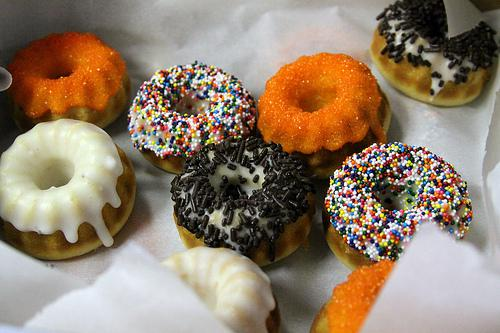Question: where was this photo taken?
Choices:
A. The pizza parlor.
B. The taco stand.
C. The grocery store.
D. The bakery.
Answer with the letter. Answer: D Question: when was this photo taken?
Choices:
A. Today.
B. Last week.
C. Yesterday.
D. Last year.
Answer with the letter. Answer: C Question: why was this photo taken?
Choices:
A. To share.
B. To keep.
C. To frame.
D. For a magazine.
Answer with the letter. Answer: D 